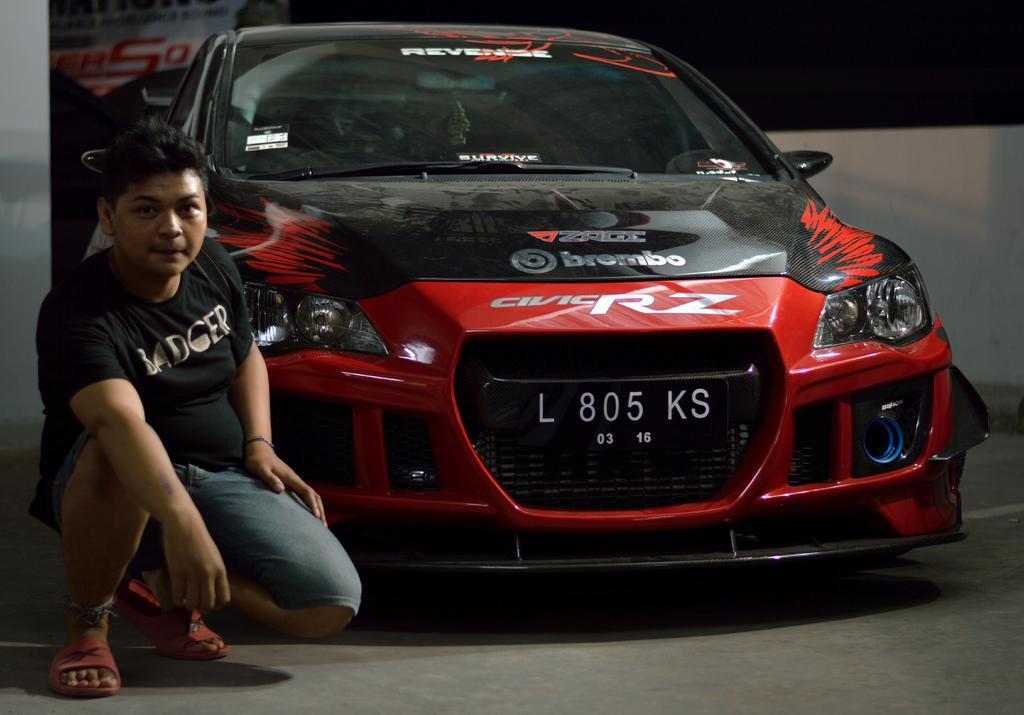Could you give a brief overview of what you see in this image? Here I can see a red color car on the ground. On the left side there is a person sitting and looking at the picture. In the background there is a banner on which I can see some text. On the right side there is a wall. The background is in black color. 